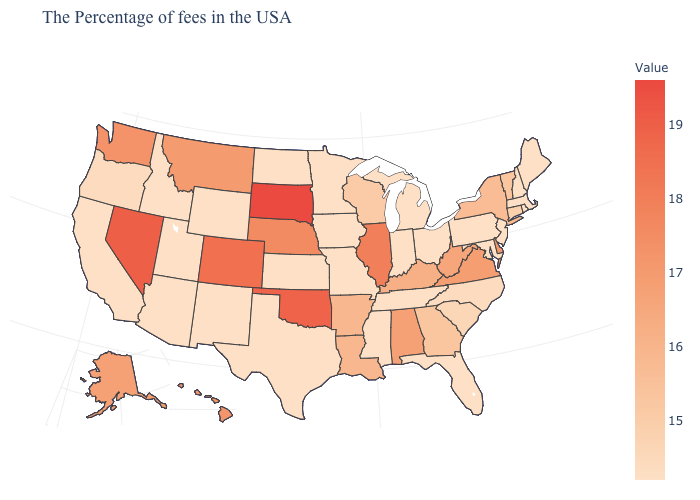Which states have the highest value in the USA?
Answer briefly. South Dakota. Does Michigan have the lowest value in the USA?
Give a very brief answer. Yes. Does the map have missing data?
Answer briefly. No. Does the map have missing data?
Quick response, please. No. Among the states that border Nebraska , which have the highest value?
Short answer required. South Dakota. Among the states that border Florida , which have the highest value?
Write a very short answer. Alabama. Among the states that border New Jersey , does Delaware have the highest value?
Be succinct. Yes. Which states have the highest value in the USA?
Keep it brief. South Dakota. 